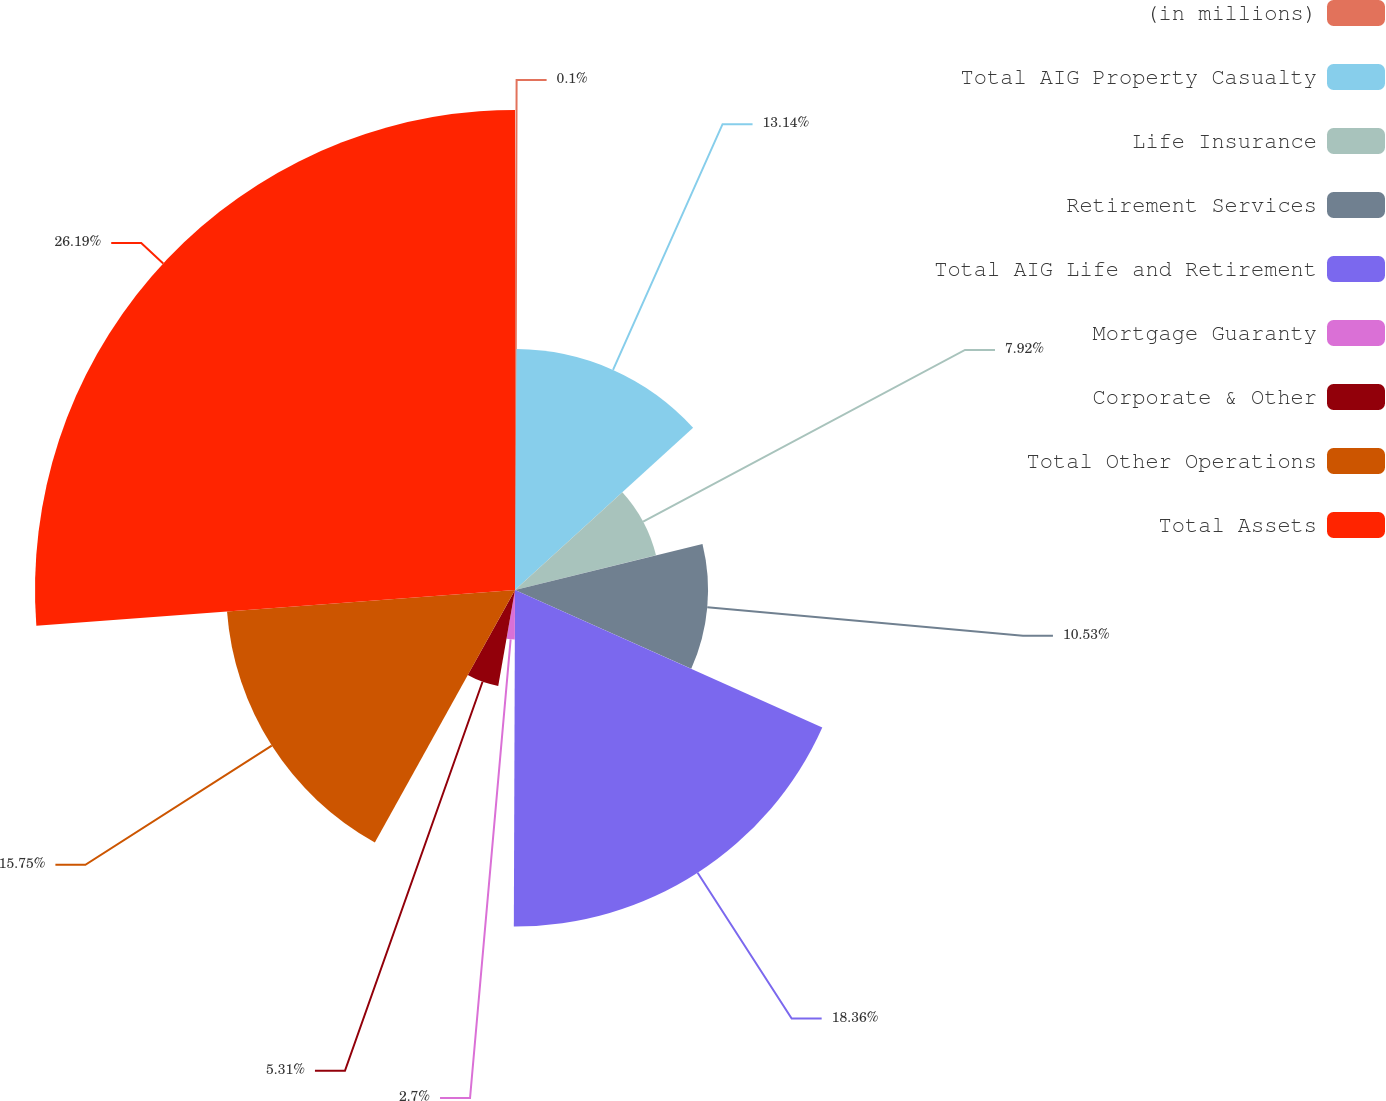Convert chart. <chart><loc_0><loc_0><loc_500><loc_500><pie_chart><fcel>(in millions)<fcel>Total AIG Property Casualty<fcel>Life Insurance<fcel>Retirement Services<fcel>Total AIG Life and Retirement<fcel>Mortgage Guaranty<fcel>Corporate & Other<fcel>Total Other Operations<fcel>Total Assets<nl><fcel>0.1%<fcel>13.14%<fcel>7.92%<fcel>10.53%<fcel>18.36%<fcel>2.7%<fcel>5.31%<fcel>15.75%<fcel>26.18%<nl></chart> 